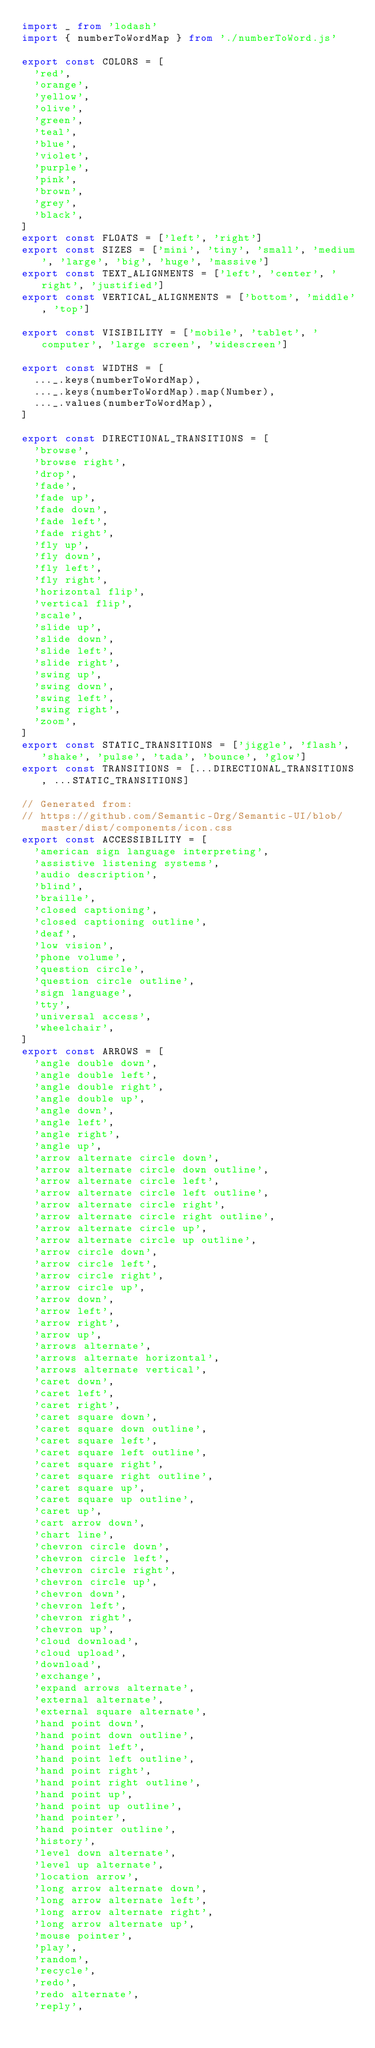Convert code to text. <code><loc_0><loc_0><loc_500><loc_500><_TypeScript_>import _ from 'lodash'
import { numberToWordMap } from './numberToWord.js'

export const COLORS = [
  'red',
  'orange',
  'yellow',
  'olive',
  'green',
  'teal',
  'blue',
  'violet',
  'purple',
  'pink',
  'brown',
  'grey',
  'black',
]
export const FLOATS = ['left', 'right']
export const SIZES = ['mini', 'tiny', 'small', 'medium', 'large', 'big', 'huge', 'massive']
export const TEXT_ALIGNMENTS = ['left', 'center', 'right', 'justified']
export const VERTICAL_ALIGNMENTS = ['bottom', 'middle', 'top']

export const VISIBILITY = ['mobile', 'tablet', 'computer', 'large screen', 'widescreen']

export const WIDTHS = [
  ..._.keys(numberToWordMap),
  ..._.keys(numberToWordMap).map(Number),
  ..._.values(numberToWordMap),
]

export const DIRECTIONAL_TRANSITIONS = [
  'browse',
  'browse right',
  'drop',
  'fade',
  'fade up',
  'fade down',
  'fade left',
  'fade right',
  'fly up',
  'fly down',
  'fly left',
  'fly right',
  'horizontal flip',
  'vertical flip',
  'scale',
  'slide up',
  'slide down',
  'slide left',
  'slide right',
  'swing up',
  'swing down',
  'swing left',
  'swing right',
  'zoom',
]
export const STATIC_TRANSITIONS = ['jiggle', 'flash', 'shake', 'pulse', 'tada', 'bounce', 'glow']
export const TRANSITIONS = [...DIRECTIONAL_TRANSITIONS, ...STATIC_TRANSITIONS]

// Generated from:
// https://github.com/Semantic-Org/Semantic-UI/blob/master/dist/components/icon.css
export const ACCESSIBILITY = [
  'american sign language interpreting',
  'assistive listening systems',
  'audio description',
  'blind',
  'braille',
  'closed captioning',
  'closed captioning outline',
  'deaf',
  'low vision',
  'phone volume',
  'question circle',
  'question circle outline',
  'sign language',
  'tty',
  'universal access',
  'wheelchair',
]
export const ARROWS = [
  'angle double down',
  'angle double left',
  'angle double right',
  'angle double up',
  'angle down',
  'angle left',
  'angle right',
  'angle up',
  'arrow alternate circle down',
  'arrow alternate circle down outline',
  'arrow alternate circle left',
  'arrow alternate circle left outline',
  'arrow alternate circle right',
  'arrow alternate circle right outline',
  'arrow alternate circle up',
  'arrow alternate circle up outline',
  'arrow circle down',
  'arrow circle left',
  'arrow circle right',
  'arrow circle up',
  'arrow down',
  'arrow left',
  'arrow right',
  'arrow up',
  'arrows alternate',
  'arrows alternate horizontal',
  'arrows alternate vertical',
  'caret down',
  'caret left',
  'caret right',
  'caret square down',
  'caret square down outline',
  'caret square left',
  'caret square left outline',
  'caret square right',
  'caret square right outline',
  'caret square up',
  'caret square up outline',
  'caret up',
  'cart arrow down',
  'chart line',
  'chevron circle down',
  'chevron circle left',
  'chevron circle right',
  'chevron circle up',
  'chevron down',
  'chevron left',
  'chevron right',
  'chevron up',
  'cloud download',
  'cloud upload',
  'download',
  'exchange',
  'expand arrows alternate',
  'external alternate',
  'external square alternate',
  'hand point down',
  'hand point down outline',
  'hand point left',
  'hand point left outline',
  'hand point right',
  'hand point right outline',
  'hand point up',
  'hand point up outline',
  'hand pointer',
  'hand pointer outline',
  'history',
  'level down alternate',
  'level up alternate',
  'location arrow',
  'long arrow alternate down',
  'long arrow alternate left',
  'long arrow alternate right',
  'long arrow alternate up',
  'mouse pointer',
  'play',
  'random',
  'recycle',
  'redo',
  'redo alternate',
  'reply',</code> 